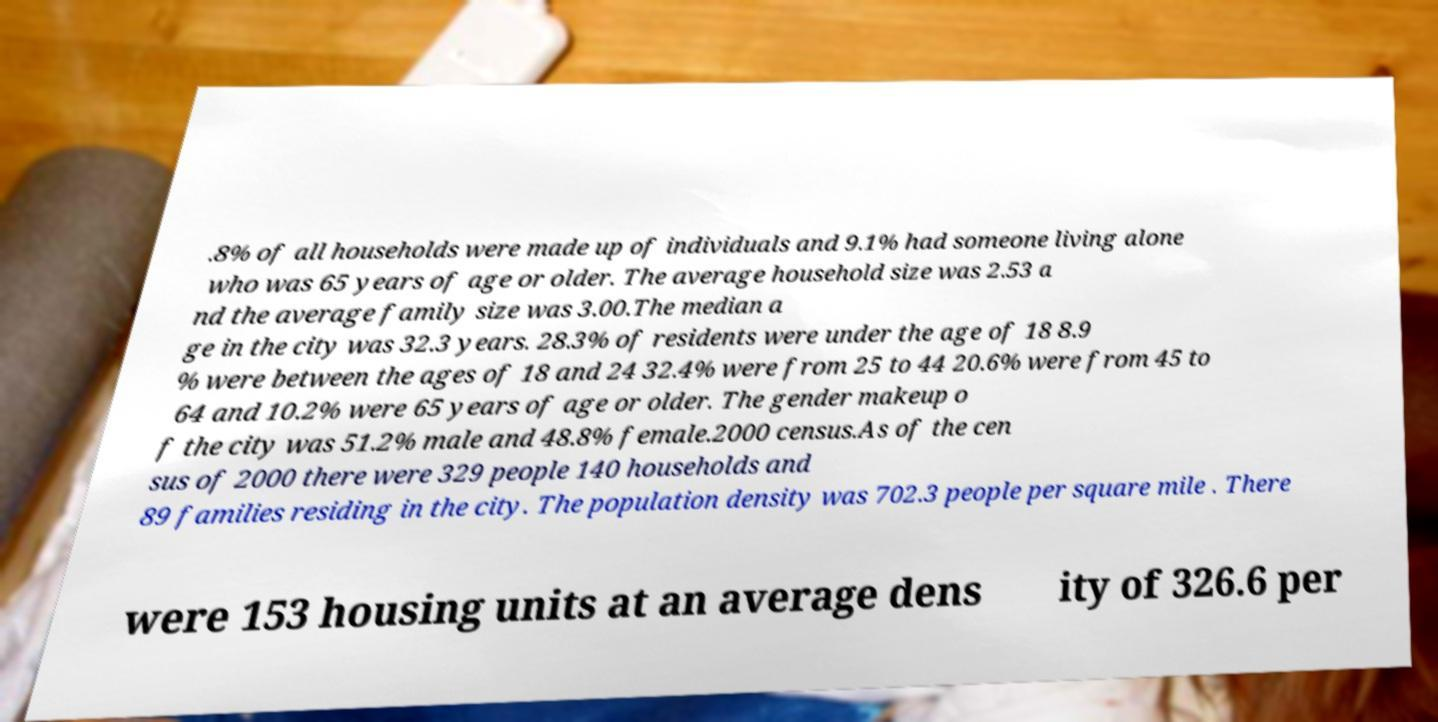For documentation purposes, I need the text within this image transcribed. Could you provide that? .8% of all households were made up of individuals and 9.1% had someone living alone who was 65 years of age or older. The average household size was 2.53 a nd the average family size was 3.00.The median a ge in the city was 32.3 years. 28.3% of residents were under the age of 18 8.9 % were between the ages of 18 and 24 32.4% were from 25 to 44 20.6% were from 45 to 64 and 10.2% were 65 years of age or older. The gender makeup o f the city was 51.2% male and 48.8% female.2000 census.As of the cen sus of 2000 there were 329 people 140 households and 89 families residing in the city. The population density was 702.3 people per square mile . There were 153 housing units at an average dens ity of 326.6 per 